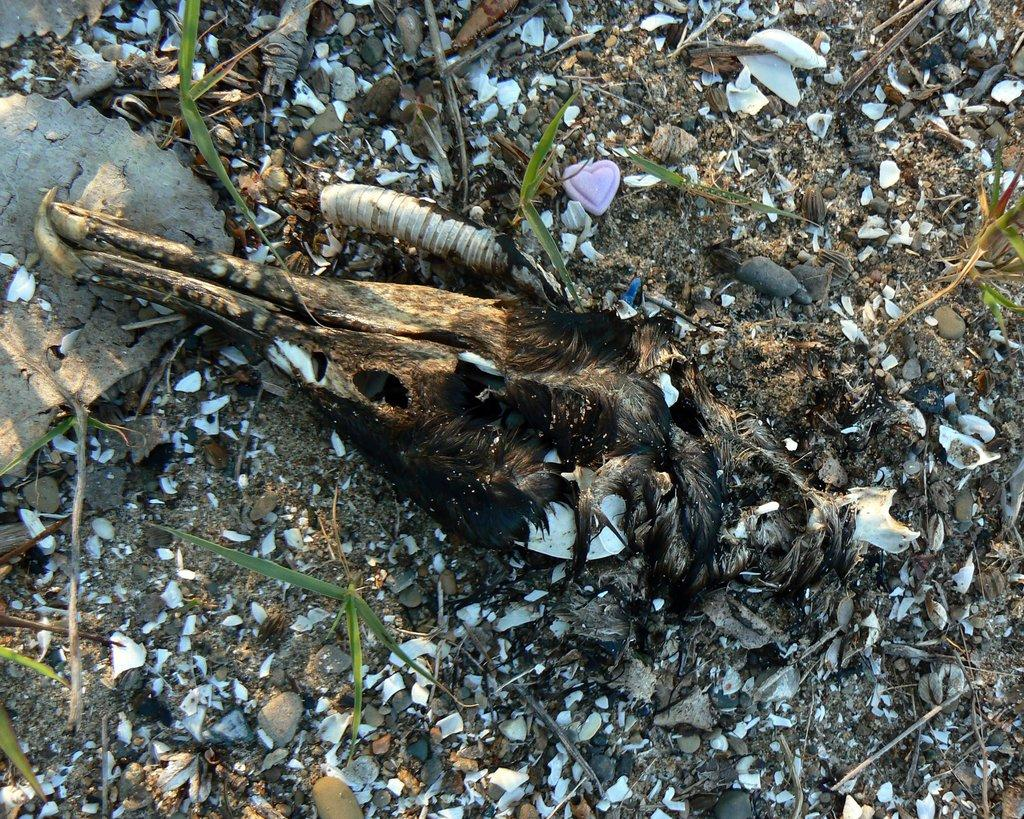What is the main subject of the image? The main subject of the image is a skull of an animal. Where is the skull located in the image? The skull is on a path in the image. What type of bed is visible in the image? There is no bed present in the image; it features a skull on a path. What is the temperature of the front of the image? The temperature of the front of the image cannot be determined from the image itself, as it is a photograph and not a representation of temperature. 